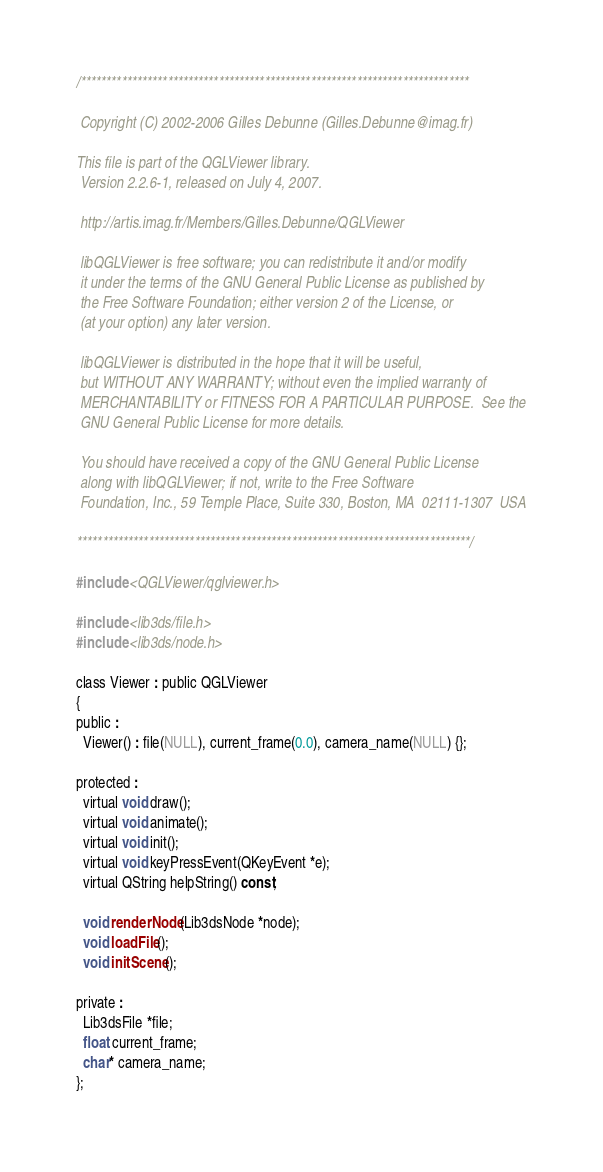<code> <loc_0><loc_0><loc_500><loc_500><_C_>/****************************************************************************

 Copyright (C) 2002-2006 Gilles Debunne (Gilles.Debunne@imag.fr)

This file is part of the QGLViewer library.
 Version 2.2.6-1, released on July 4, 2007.

 http://artis.imag.fr/Members/Gilles.Debunne/QGLViewer

 libQGLViewer is free software; you can redistribute it and/or modify
 it under the terms of the GNU General Public License as published by
 the Free Software Foundation; either version 2 of the License, or
 (at your option) any later version.

 libQGLViewer is distributed in the hope that it will be useful,
 but WITHOUT ANY WARRANTY; without even the implied warranty of
 MERCHANTABILITY or FITNESS FOR A PARTICULAR PURPOSE.  See the
 GNU General Public License for more details.

 You should have received a copy of the GNU General Public License
 along with libQGLViewer; if not, write to the Free Software
 Foundation, Inc., 59 Temple Place, Suite 330, Boston, MA  02111-1307  USA

*****************************************************************************/

#include <QGLViewer/qglviewer.h>

#include <lib3ds/file.h>
#include <lib3ds/node.h>

class Viewer : public QGLViewer
{
public :
  Viewer() : file(NULL), current_frame(0.0), camera_name(NULL) {};

protected :
  virtual void draw();
  virtual void animate();
  virtual void init();
  virtual void keyPressEvent(QKeyEvent *e);
  virtual QString helpString() const;

  void renderNode(Lib3dsNode *node);
  void loadFile();
  void initScene();

private :
  Lib3dsFile *file;
  float current_frame;
  char* camera_name;
};
</code> 